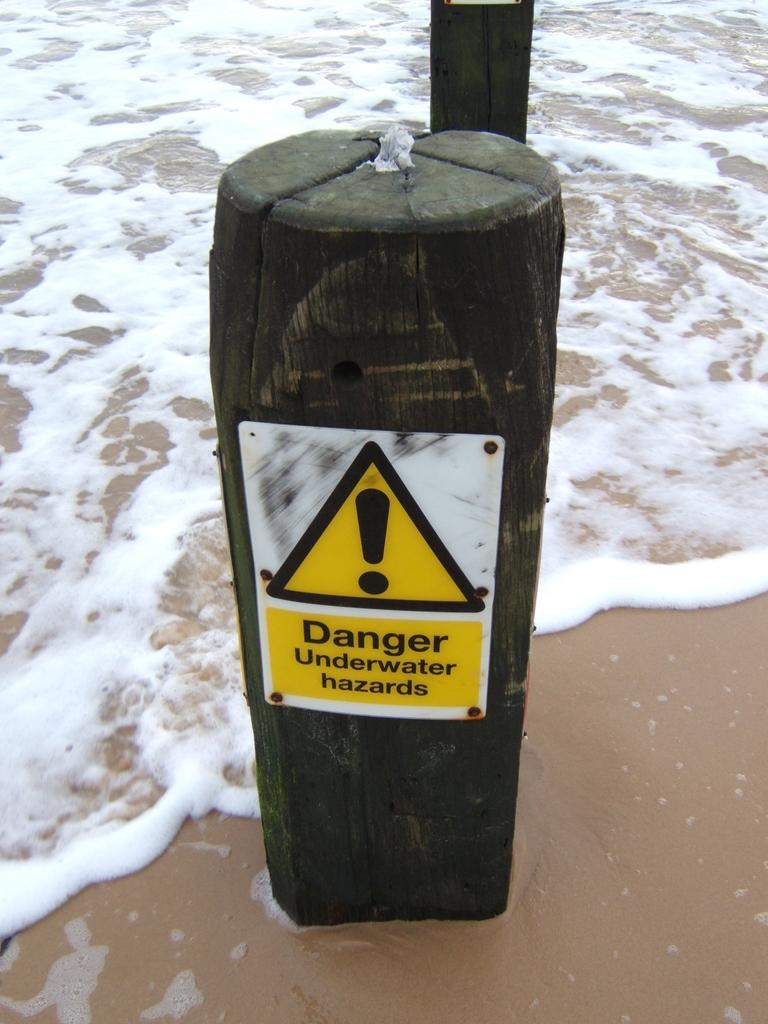<image>
Give a short and clear explanation of the subsequent image. a yellow sign on a post saying danger, underwater hazards 